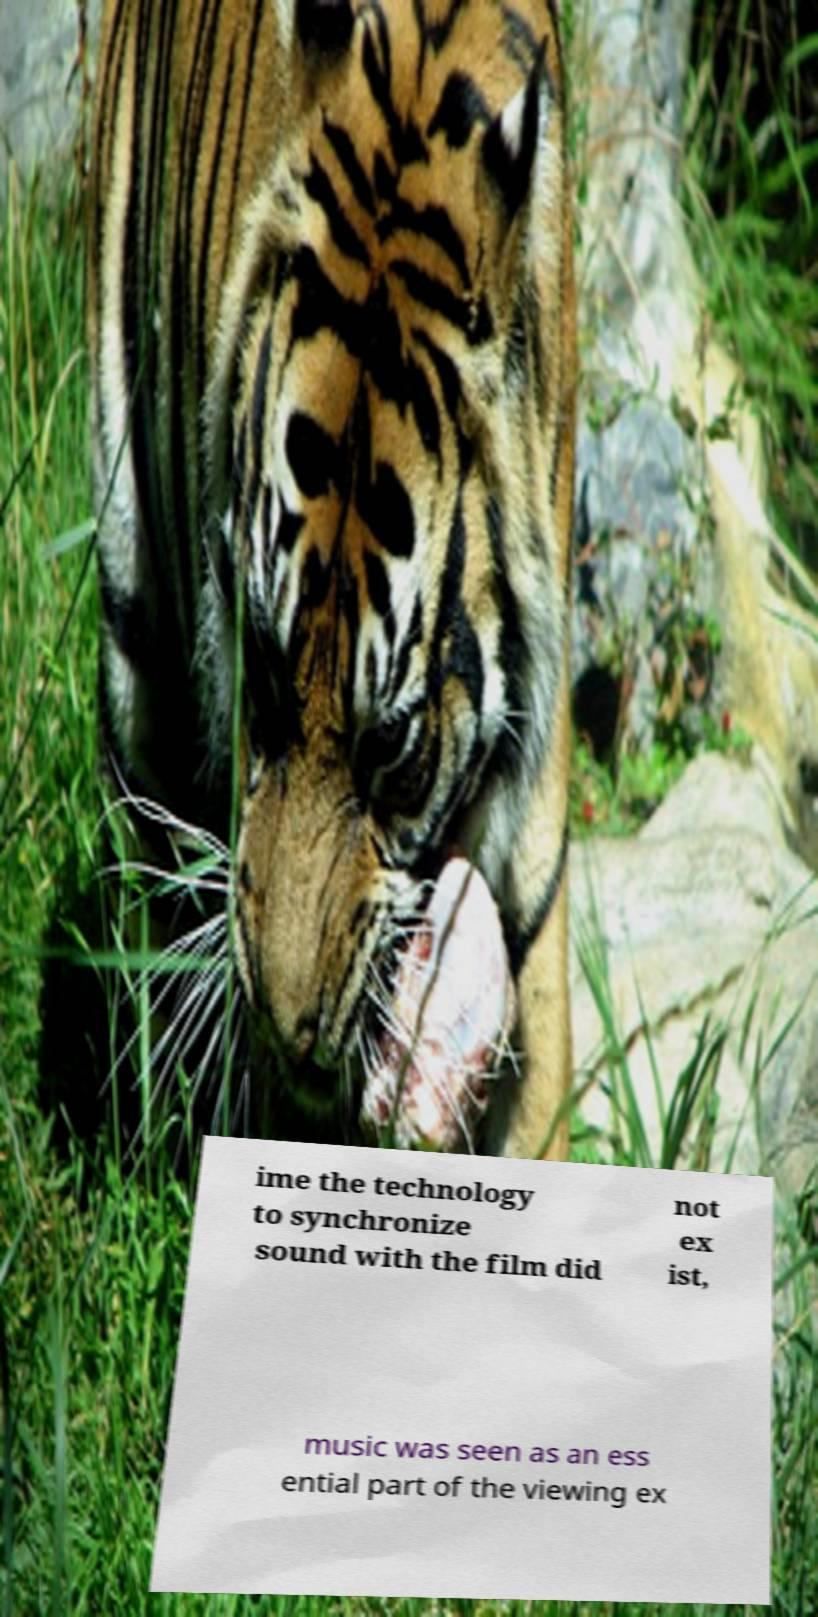Can you accurately transcribe the text from the provided image for me? ime the technology to synchronize sound with the film did not ex ist, music was seen as an ess ential part of the viewing ex 